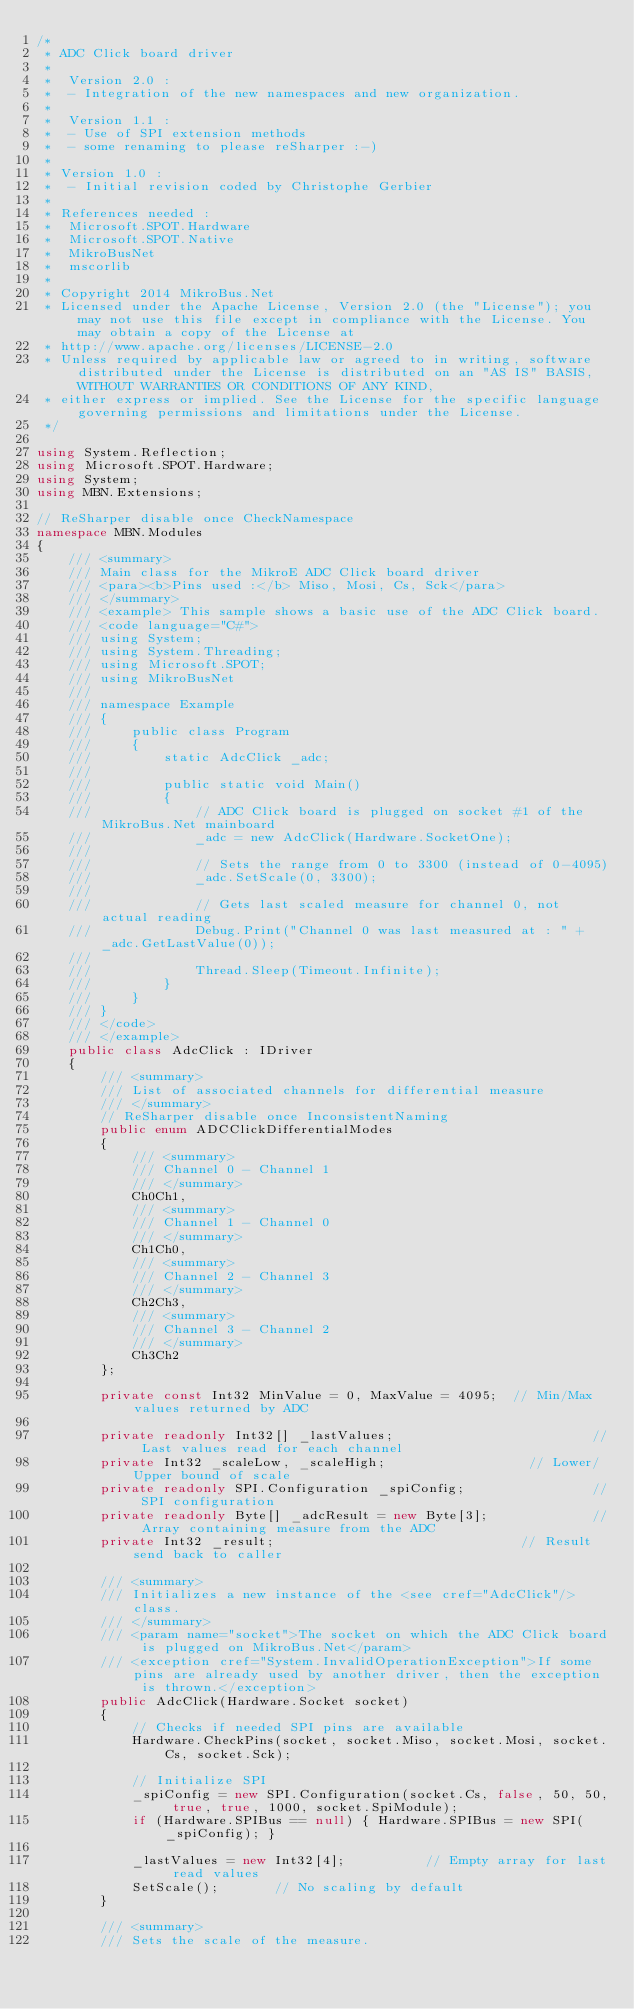<code> <loc_0><loc_0><loc_500><loc_500><_C#_>/*
 * ADC Click board driver
 * 
 *  Version 2.0 :
 *  - Integration of the new namespaces and new organization.
 *  
 *  Version 1.1 :
 *  - Use of SPI extension methods
 *  - some renaming to please reSharper :-)
 *  
 * Version 1.0 :
 *  - Initial revision coded by Christophe Gerbier
 * 
 * References needed :
 *  Microsoft.SPOT.Hardware
 *  Microsoft.SPOT.Native
 *  MikroBusNet
 *  mscorlib
 *  
 * Copyright 2014 MikroBus.Net
 * Licensed under the Apache License, Version 2.0 (the "License"); you may not use this file except in compliance with the License. You may obtain a copy of the License at
 * http://www.apache.org/licenses/LICENSE-2.0
 * Unless required by applicable law or agreed to in writing, software distributed under the License is distributed on an "AS IS" BASIS, WITHOUT WARRANTIES OR CONDITIONS OF ANY KIND, 
 * either express or implied. See the License for the specific language governing permissions and limitations under the License.
 */

using System.Reflection;
using Microsoft.SPOT.Hardware;
using System;
using MBN.Extensions;

// ReSharper disable once CheckNamespace
namespace MBN.Modules
{
    /// <summary>
    /// Main class for the MikroE ADC Click board driver
    /// <para><b>Pins used :</b> Miso, Mosi, Cs, Sck</para>
    /// </summary>
    /// <example> This sample shows a basic use of the ADC Click board.
    /// <code language="C#">
    /// using System;
    /// using System.Threading;
    /// using Microsoft.SPOT;
    /// using MikroBusNet
    ///
    /// namespace Example
    /// {
    ///     public class Program
    ///     {
    ///         static AdcClick _adc;
    ///         
    ///         public static void Main()
    ///         {
    ///             // ADC Click board is plugged on socket #1 of the MikroBus.Net mainboard
    ///             _adc = new AdcClick(Hardware.SocketOne);
    ///
    ///             // Sets the range from 0 to 3300 (instead of 0-4095)
    ///             _adc.SetScale(0, 3300);
    /// 
    ///             // Gets last scaled measure for channel 0, not actual reading
    ///             Debug.Print("Channel 0 was last measured at : " + _adc.GetLastValue(0));
    /// 
    ///             Thread.Sleep(Timeout.Infinite);
    ///         }
    ///     }
    /// }
    /// </code>
    /// </example>
    public class AdcClick : IDriver
    {
        /// <summary>
        /// List of associated channels for differential measure
        /// </summary>
        // ReSharper disable once InconsistentNaming
        public enum ADCClickDifferentialModes
        {
            /// <summary>
            /// Channel 0 - Channel 1
            /// </summary>
            Ch0Ch1,
            /// <summary>
            /// Channel 1 - Channel 0
            /// </summary>
            Ch1Ch0,
            /// <summary>
            /// Channel 2 - Channel 3
            /// </summary>
            Ch2Ch3,
            /// <summary>
            /// Channel 3 - Channel 2
            /// </summary>
            Ch3Ch2
        };

        private const Int32 MinValue = 0, MaxValue = 4095;  // Min/Max values returned by ADC

        private readonly Int32[] _lastValues;                         // Last values read for each channel
        private Int32 _scaleLow, _scaleHigh;                  // Lower/Upper bound of scale
        private readonly SPI.Configuration _spiConfig;                // SPI configuration
        private readonly Byte[] _adcResult = new Byte[3];             // Array containing measure from the ADC
        private Int32 _result;                               // Result send back to caller

        /// <summary>
        /// Initializes a new instance of the <see cref="AdcClick"/> class.
        /// </summary>
        /// <param name="socket">The socket on which the ADC Click board is plugged on MikroBus.Net</param>
        /// <exception cref="System.InvalidOperationException">If some pins are already used by another driver, then the exception is thrown.</exception>
        public AdcClick(Hardware.Socket socket)
        {
            // Checks if needed SPI pins are available
            Hardware.CheckPins(socket, socket.Miso, socket.Mosi, socket.Cs, socket.Sck);

            // Initialize SPI
            _spiConfig = new SPI.Configuration(socket.Cs, false, 50, 50, true, true, 1000, socket.SpiModule);
            if (Hardware.SPIBus == null) { Hardware.SPIBus = new SPI(_spiConfig); }

            _lastValues = new Int32[4];          // Empty array for last read values
            SetScale();       // No scaling by default
        }

        /// <summary>
        /// Sets the scale of the measure.</code> 